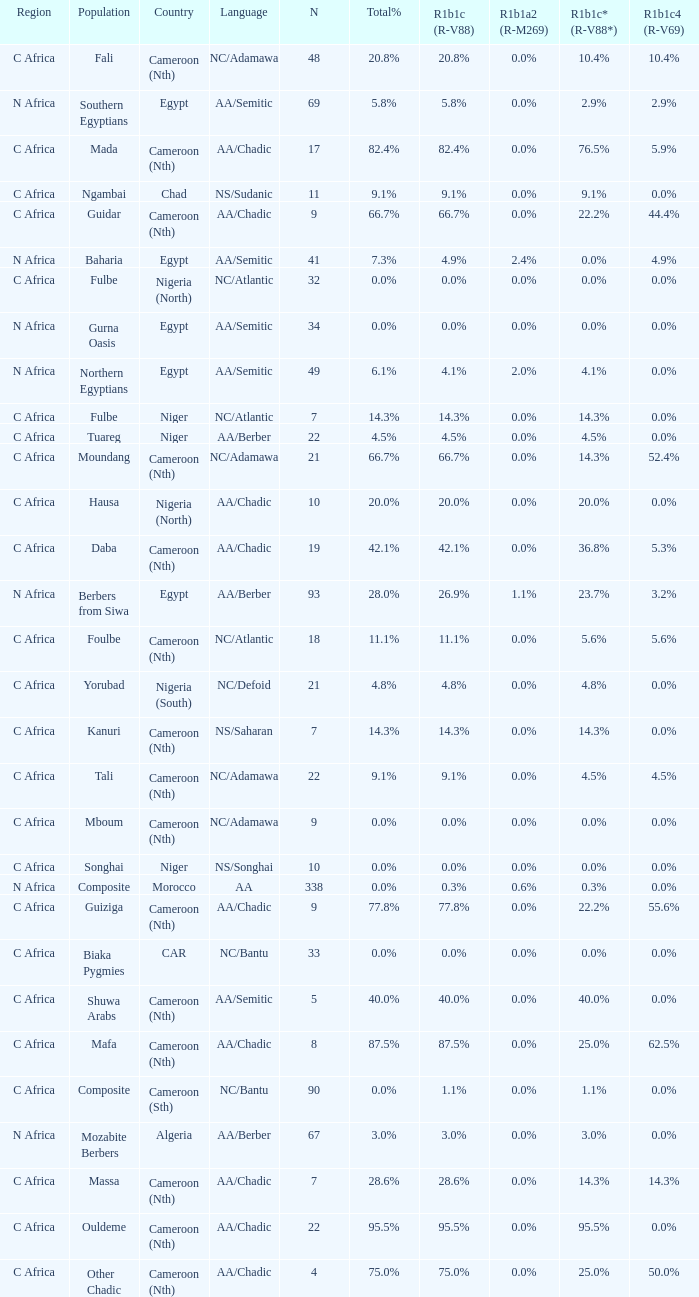What languages are spoken in Niger with r1b1c (r-v88) of 0.0%? NS/Songhai. Give me the full table as a dictionary. {'header': ['Region', 'Population', 'Country', 'Language', 'N', 'Total%', 'R1b1c (R-V88)', 'R1b1a2 (R-M269)', 'R1b1c* (R-V88*)', 'R1b1c4 (R-V69)'], 'rows': [['C Africa', 'Fali', 'Cameroon (Nth)', 'NC/Adamawa', '48', '20.8%', '20.8%', '0.0%', '10.4%', '10.4%'], ['N Africa', 'Southern Egyptians', 'Egypt', 'AA/Semitic', '69', '5.8%', '5.8%', '0.0%', '2.9%', '2.9%'], ['C Africa', 'Mada', 'Cameroon (Nth)', 'AA/Chadic', '17', '82.4%', '82.4%', '0.0%', '76.5%', '5.9%'], ['C Africa', 'Ngambai', 'Chad', 'NS/Sudanic', '11', '9.1%', '9.1%', '0.0%', '9.1%', '0.0%'], ['C Africa', 'Guidar', 'Cameroon (Nth)', 'AA/Chadic', '9', '66.7%', '66.7%', '0.0%', '22.2%', '44.4%'], ['N Africa', 'Baharia', 'Egypt', 'AA/Semitic', '41', '7.3%', '4.9%', '2.4%', '0.0%', '4.9%'], ['C Africa', 'Fulbe', 'Nigeria (North)', 'NC/Atlantic', '32', '0.0%', '0.0%', '0.0%', '0.0%', '0.0%'], ['N Africa', 'Gurna Oasis', 'Egypt', 'AA/Semitic', '34', '0.0%', '0.0%', '0.0%', '0.0%', '0.0%'], ['N Africa', 'Northern Egyptians', 'Egypt', 'AA/Semitic', '49', '6.1%', '4.1%', '2.0%', '4.1%', '0.0%'], ['C Africa', 'Fulbe', 'Niger', 'NC/Atlantic', '7', '14.3%', '14.3%', '0.0%', '14.3%', '0.0%'], ['C Africa', 'Tuareg', 'Niger', 'AA/Berber', '22', '4.5%', '4.5%', '0.0%', '4.5%', '0.0%'], ['C Africa', 'Moundang', 'Cameroon (Nth)', 'NC/Adamawa', '21', '66.7%', '66.7%', '0.0%', '14.3%', '52.4%'], ['C Africa', 'Hausa', 'Nigeria (North)', 'AA/Chadic', '10', '20.0%', '20.0%', '0.0%', '20.0%', '0.0%'], ['C Africa', 'Daba', 'Cameroon (Nth)', 'AA/Chadic', '19', '42.1%', '42.1%', '0.0%', '36.8%', '5.3%'], ['N Africa', 'Berbers from Siwa', 'Egypt', 'AA/Berber', '93', '28.0%', '26.9%', '1.1%', '23.7%', '3.2%'], ['C Africa', 'Foulbe', 'Cameroon (Nth)', 'NC/Atlantic', '18', '11.1%', '11.1%', '0.0%', '5.6%', '5.6%'], ['C Africa', 'Yorubad', 'Nigeria (South)', 'NC/Defoid', '21', '4.8%', '4.8%', '0.0%', '4.8%', '0.0%'], ['C Africa', 'Kanuri', 'Cameroon (Nth)', 'NS/Saharan', '7', '14.3%', '14.3%', '0.0%', '14.3%', '0.0%'], ['C Africa', 'Tali', 'Cameroon (Nth)', 'NC/Adamawa', '22', '9.1%', '9.1%', '0.0%', '4.5%', '4.5%'], ['C Africa', 'Mboum', 'Cameroon (Nth)', 'NC/Adamawa', '9', '0.0%', '0.0%', '0.0%', '0.0%', '0.0%'], ['C Africa', 'Songhai', 'Niger', 'NS/Songhai', '10', '0.0%', '0.0%', '0.0%', '0.0%', '0.0%'], ['N Africa', 'Composite', 'Morocco', 'AA', '338', '0.0%', '0.3%', '0.6%', '0.3%', '0.0%'], ['C Africa', 'Guiziga', 'Cameroon (Nth)', 'AA/Chadic', '9', '77.8%', '77.8%', '0.0%', '22.2%', '55.6%'], ['C Africa', 'Biaka Pygmies', 'CAR', 'NC/Bantu', '33', '0.0%', '0.0%', '0.0%', '0.0%', '0.0%'], ['C Africa', 'Shuwa Arabs', 'Cameroon (Nth)', 'AA/Semitic', '5', '40.0%', '40.0%', '0.0%', '40.0%', '0.0%'], ['C Africa', 'Mafa', 'Cameroon (Nth)', 'AA/Chadic', '8', '87.5%', '87.5%', '0.0%', '25.0%', '62.5%'], ['C Africa', 'Composite', 'Cameroon (Sth)', 'NC/Bantu', '90', '0.0%', '1.1%', '0.0%', '1.1%', '0.0%'], ['N Africa', 'Mozabite Berbers', 'Algeria', 'AA/Berber', '67', '3.0%', '3.0%', '0.0%', '3.0%', '0.0%'], ['C Africa', 'Massa', 'Cameroon (Nth)', 'AA/Chadic', '7', '28.6%', '28.6%', '0.0%', '14.3%', '14.3%'], ['C Africa', 'Ouldeme', 'Cameroon (Nth)', 'AA/Chadic', '22', '95.5%', '95.5%', '0.0%', '95.5%', '0.0%'], ['C Africa', 'Other Chadic', 'Cameroon (Nth)', 'AA/Chadic', '4', '75.0%', '75.0%', '0.0%', '25.0%', '50.0%']]} 